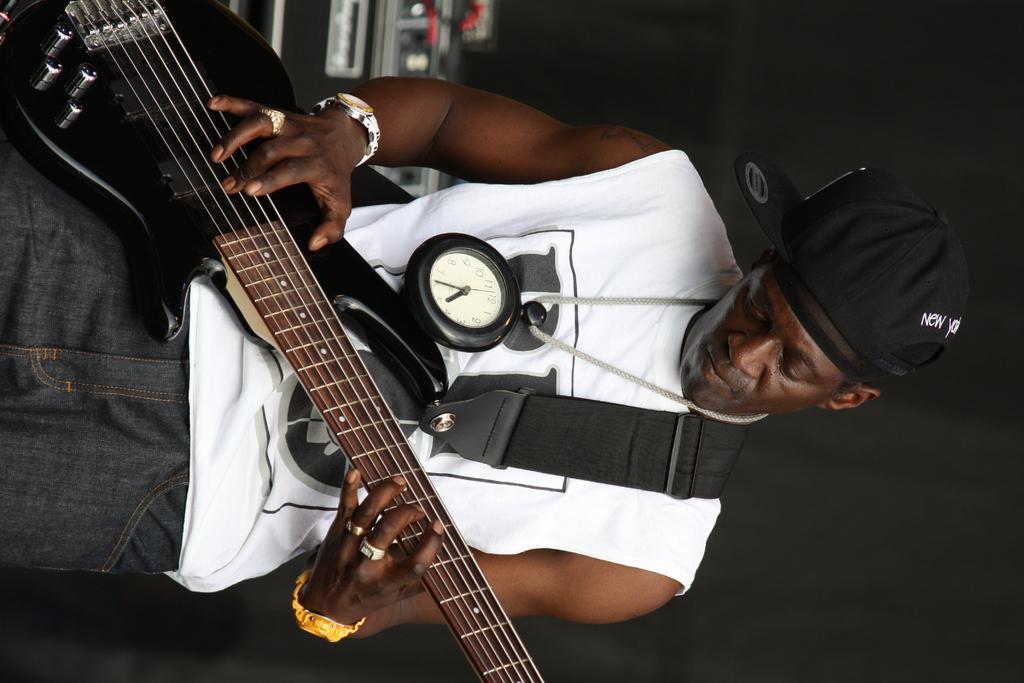Can you describe this image briefly? This picture is of inside the room. On the left there is a man standing, wearing a white color t-shirt and playing guitar. In the background we can see the wall and some musical instruments. 